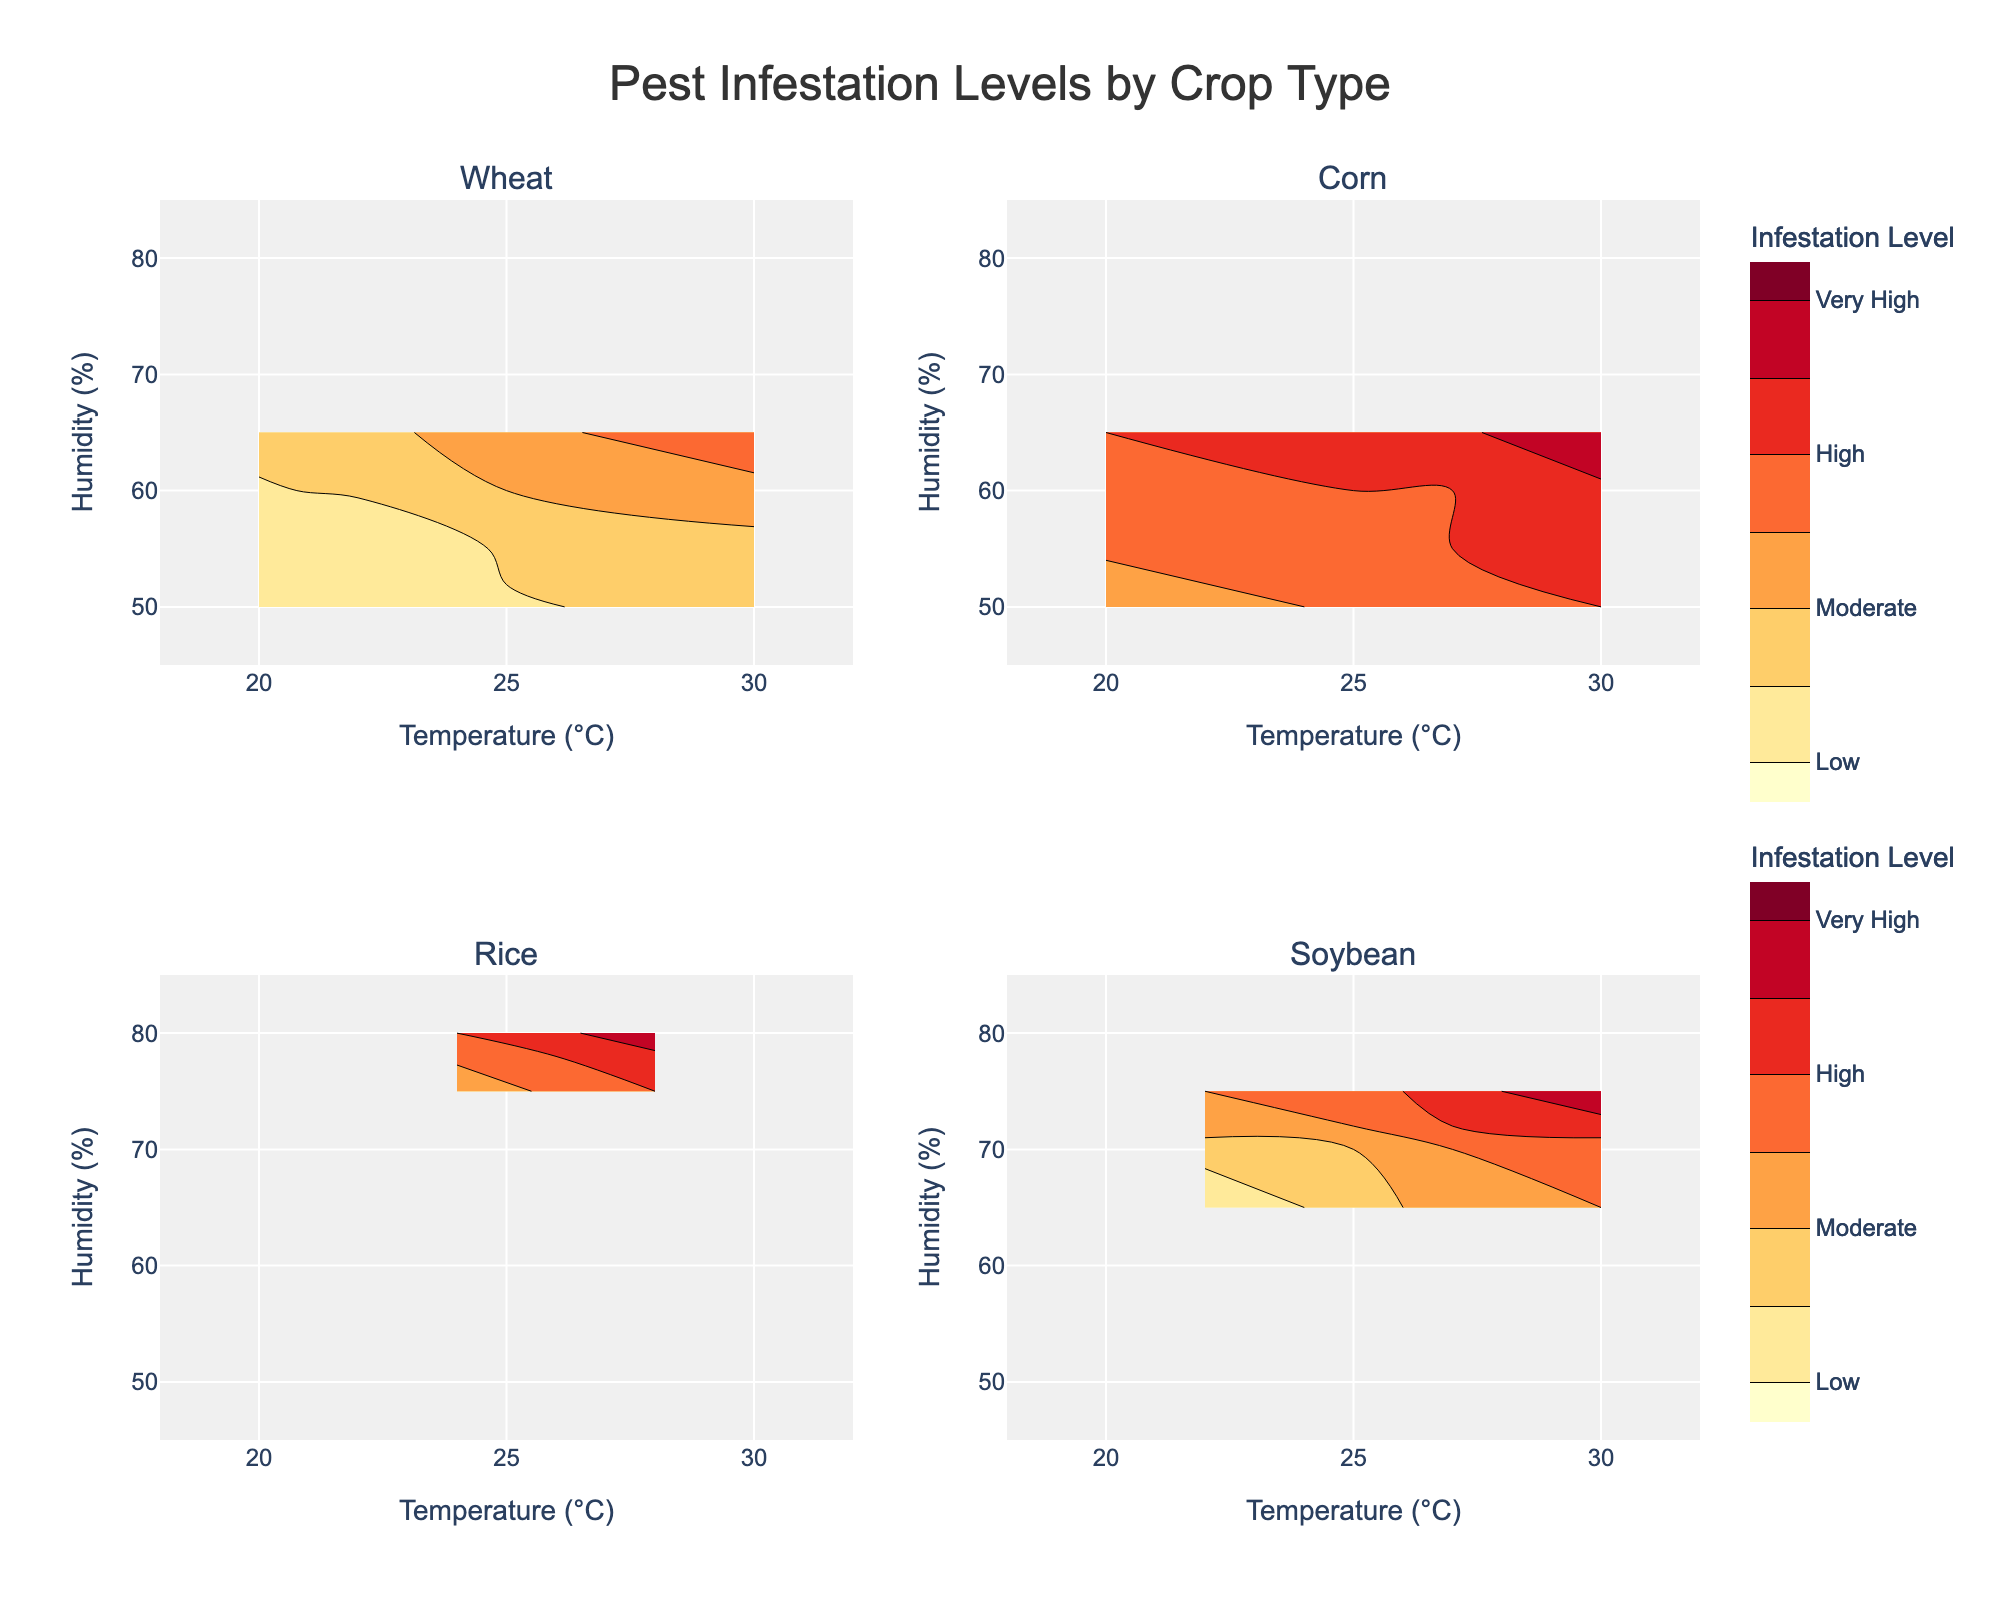What is the general trend of pest infestation levels at higher temperatures for Corn? By inspecting the contour plot for Corn, it shows that as the temperature increases, the pest infestation levels transition from Moderate at 20°C to Very High at 30°C.
Answer: Pest infestation levels increase with higher temperatures Which crop type has the highest pest infestation level observed at the lowest temperatures displayed on the plot? Looking at the contour plots, Corn has a Moderate pest infestation level at 20°C, which is the highest among the crops at the lowest temperature displayed.
Answer: Corn How does the pest infestation level for Wheat at 22°C and 55% humidity compare to that for Soybean at the same conditions? Wheat at 22°C and 55% humidity has Low pest infestation levels, while Soybean at the closest condition (22°C and 65% humidity) also has Low infestation levels. Therefore, both crops have Low pest infestation levels near these temperature and humidity conditions.
Answer: Low for both Wheat and Soybean Which crop type shows a transition to 'Very High' pest infestation levels at the lowest combination of temperature and humidity? Observing the contour plots, 'Very High' infestation levels in Corn occur at 27°C and 60% humidity, which is the lowest temperature and humidity combination across the crops that transitions to 'Very High'.
Answer: Corn At a humidity of 75%, which crop types exhibit High pest infestation at any temperature? Referring to the contour plots, Rice and Soybean exhibit High pest infestation at 75% humidity. Rice shows High levels at 26°C and Soybean shows High at 27°C.
Answer: Rice and Soybean Which crop type demonstrates the widest range of temperature for Moderate pest infestation levels, and what is that range? Inspecting the plots, Wheat shows a Moderate pest infestation level starting at 25°C and ending at 30°C resulting in a range of 5°C.
Answer: Wheat, 5°C In general, how do humidity levels affect pest infestation levels for Rice at temperatures between 24°C and 28°C? For Rice, within the temperature range of 24°C to 28°C, increasing humidity from 75% to 80% changes the pest infestation level from Moderate to Very High.
Answer: Higher humidity increases pest infestation Do pest infestation levels for Wheat ever exceed 'Moderate' below 25°C? From the contour plot for Wheat, pest infestation levels remain 'Low' below 25°C and only transition to 'Moderate' at 25°C and above.
Answer: No Is there any crop type that consistently maintains high pest infestation levels across a broad range of temperatures and humidities? The contour plots reveal that Corn and Rice maintain high pest infestation levels over a wide range of temperatures and humidities, especially for Corn with levels transitioning to 'High' and 'Very High' between 25°C-30°C and 55%-65% humidity.
Answer: Corn and Rice 